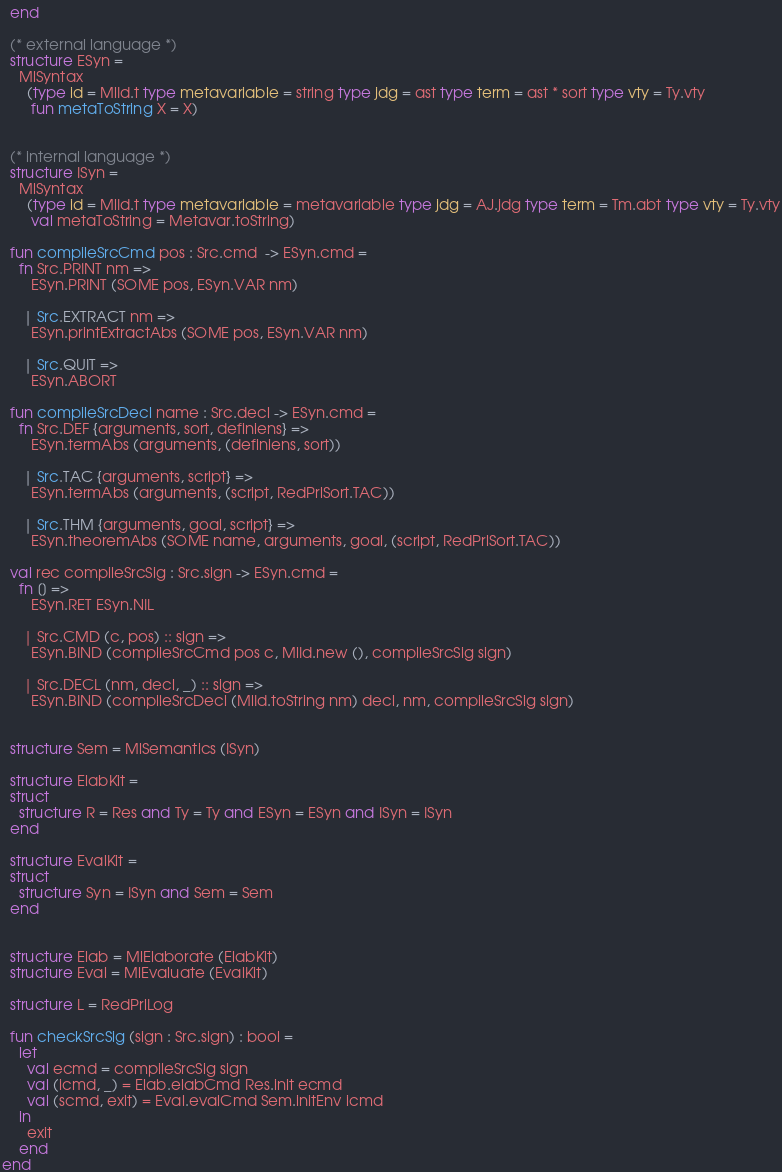<code> <loc_0><loc_0><loc_500><loc_500><_SML_>  end

  (* external language *)
  structure ESyn =
    MlSyntax
      (type id = MlId.t type metavariable = string type jdg = ast type term = ast * sort type vty = Ty.vty
       fun metaToString X = X)


  (* internal language *)
  structure ISyn =
    MlSyntax
      (type id = MlId.t type metavariable = metavariable type jdg = AJ.jdg type term = Tm.abt type vty = Ty.vty
       val metaToString = Metavar.toString)

  fun compileSrcCmd pos : Src.cmd  -> ESyn.cmd =
    fn Src.PRINT nm =>
       ESyn.PRINT (SOME pos, ESyn.VAR nm)

     | Src.EXTRACT nm =>
       ESyn.printExtractAbs (SOME pos, ESyn.VAR nm)

     | Src.QUIT =>
       ESyn.ABORT

  fun compileSrcDecl name : Src.decl -> ESyn.cmd =
    fn Src.DEF {arguments, sort, definiens} =>
       ESyn.termAbs (arguments, (definiens, sort))

     | Src.TAC {arguments, script} => 
       ESyn.termAbs (arguments, (script, RedPrlSort.TAC))

     | Src.THM {arguments, goal, script} =>
       ESyn.theoremAbs (SOME name, arguments, goal, (script, RedPrlSort.TAC))

  val rec compileSrcSig : Src.sign -> ESyn.cmd =
    fn [] =>
       ESyn.RET ESyn.NIL

     | Src.CMD (c, pos) :: sign =>
       ESyn.BIND (compileSrcCmd pos c, MlId.new (), compileSrcSig sign)

     | Src.DECL (nm, decl, _) :: sign =>
       ESyn.BIND (compileSrcDecl (MlId.toString nm) decl, nm, compileSrcSig sign)
  
  
  structure Sem = MlSemantics (ISyn)

  structure ElabKit = 
  struct
    structure R = Res and Ty = Ty and ESyn = ESyn and ISyn = ISyn
  end

  structure EvalKit = 
  struct
    structure Syn = ISyn and Sem = Sem
  end


  structure Elab = MlElaborate (ElabKit)
  structure Eval = MlEvaluate (EvalKit)

  structure L = RedPrlLog

  fun checkSrcSig (sign : Src.sign) : bool =
    let
      val ecmd = compileSrcSig sign
      val (icmd, _) = Elab.elabCmd Res.init ecmd
      val (scmd, exit) = Eval.evalCmd Sem.initEnv icmd
    in
      exit
    end
end
</code> 